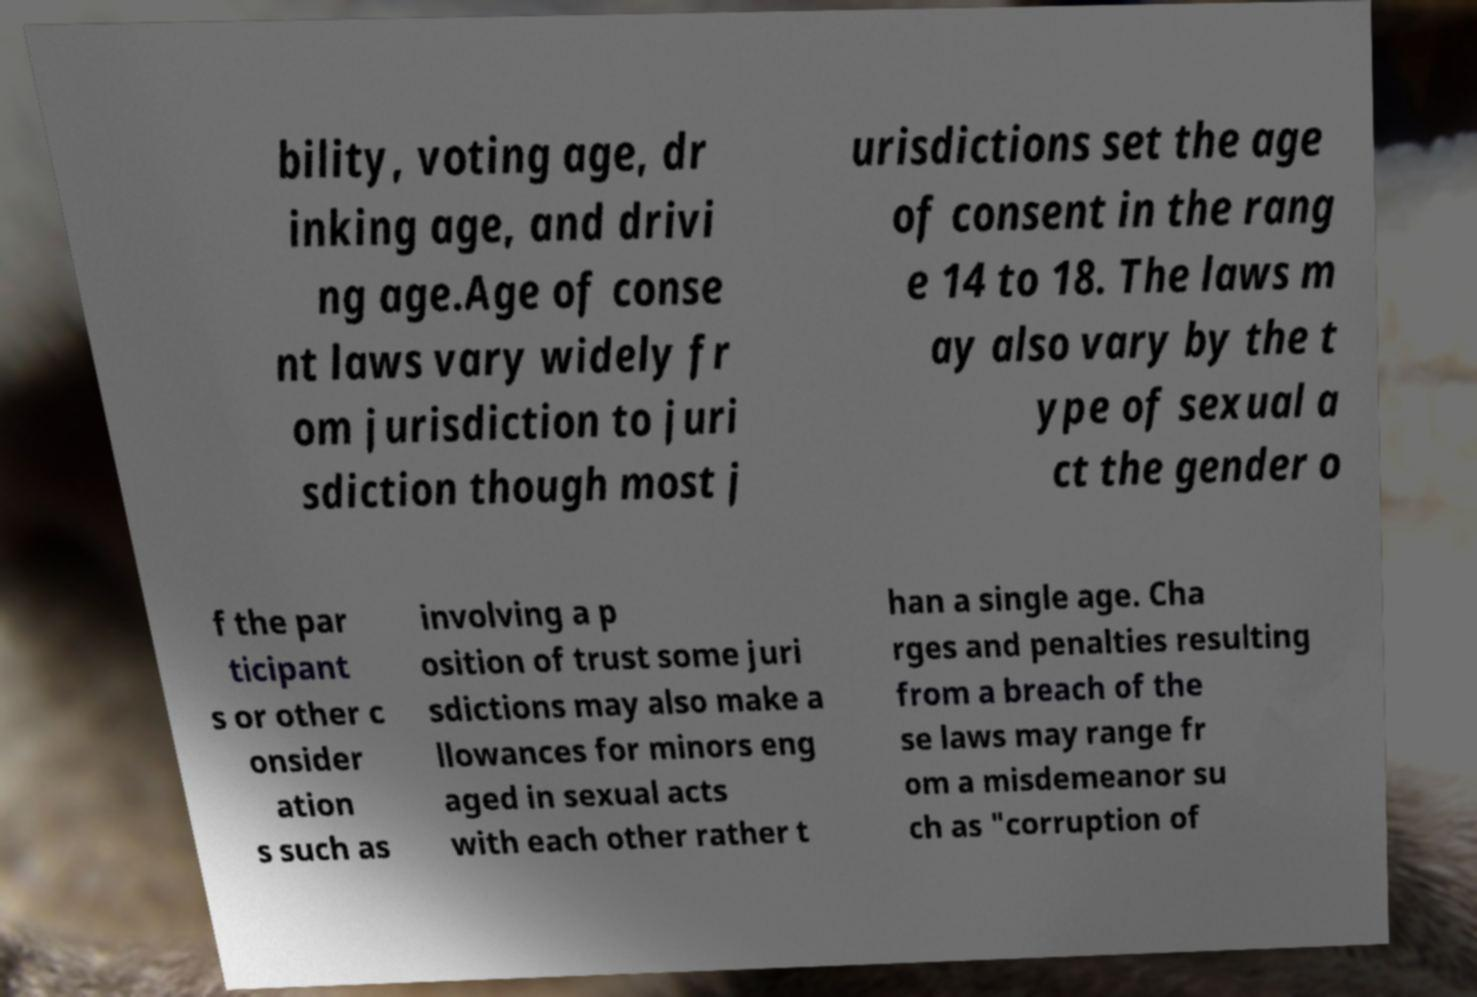I need the written content from this picture converted into text. Can you do that? bility, voting age, dr inking age, and drivi ng age.Age of conse nt laws vary widely fr om jurisdiction to juri sdiction though most j urisdictions set the age of consent in the rang e 14 to 18. The laws m ay also vary by the t ype of sexual a ct the gender o f the par ticipant s or other c onsider ation s such as involving a p osition of trust some juri sdictions may also make a llowances for minors eng aged in sexual acts with each other rather t han a single age. Cha rges and penalties resulting from a breach of the se laws may range fr om a misdemeanor su ch as "corruption of 